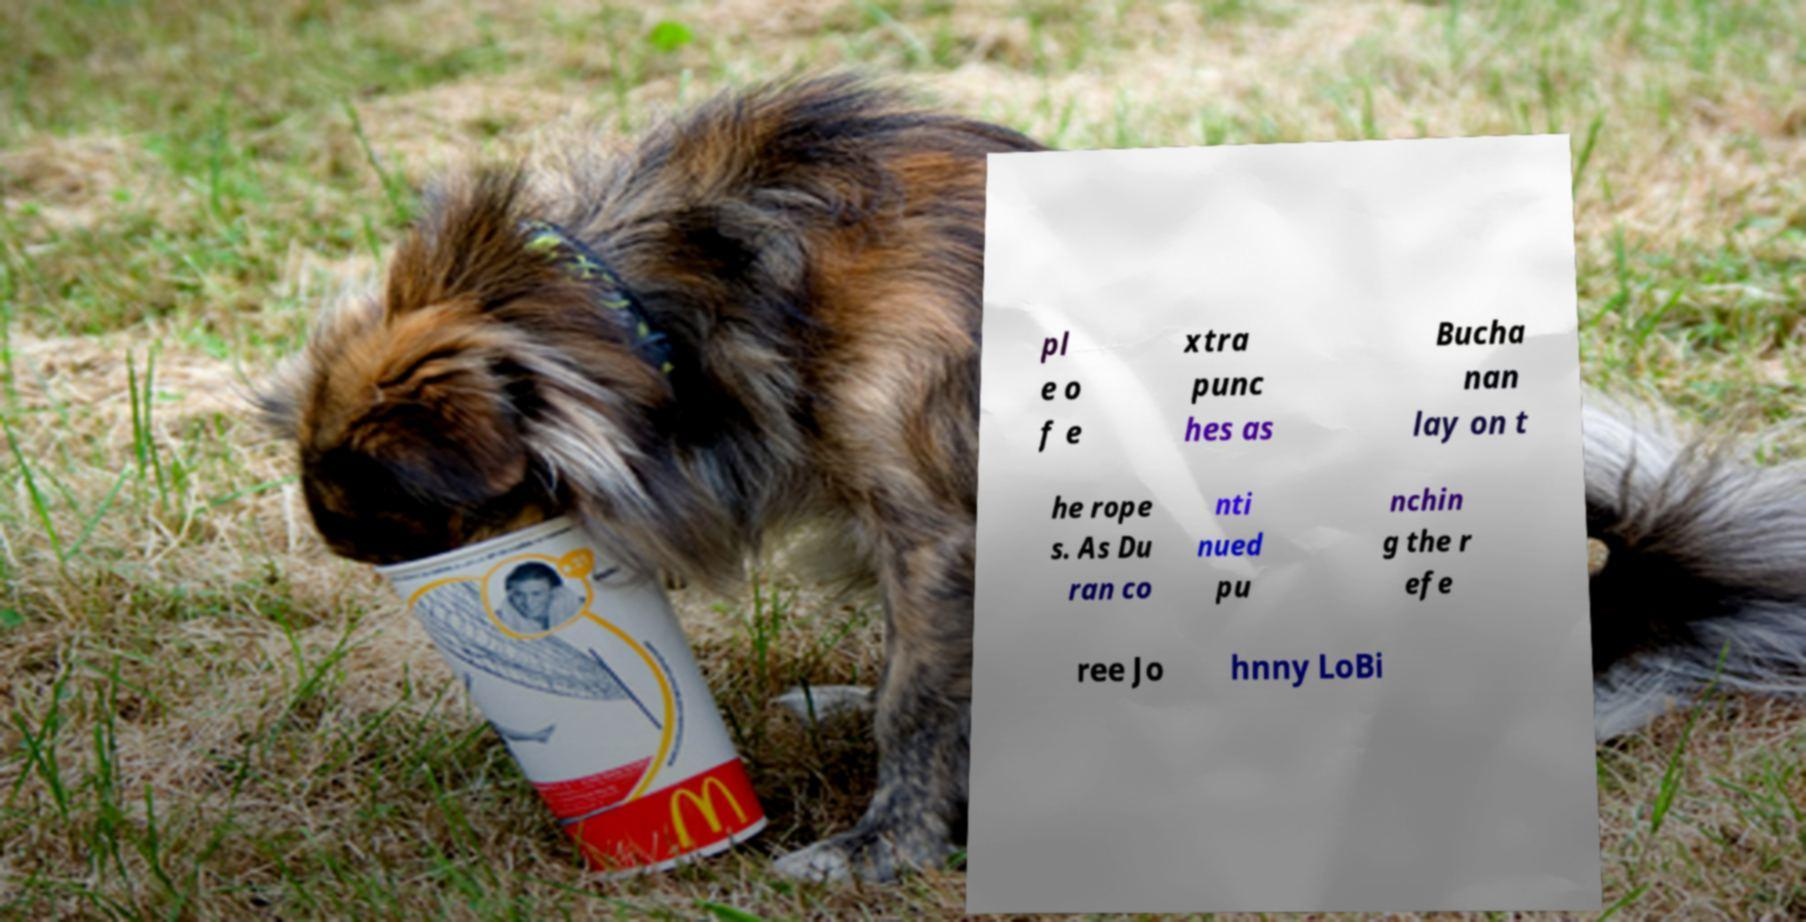What messages or text are displayed in this image? I need them in a readable, typed format. pl e o f e xtra punc hes as Bucha nan lay on t he rope s. As Du ran co nti nued pu nchin g the r efe ree Jo hnny LoBi 